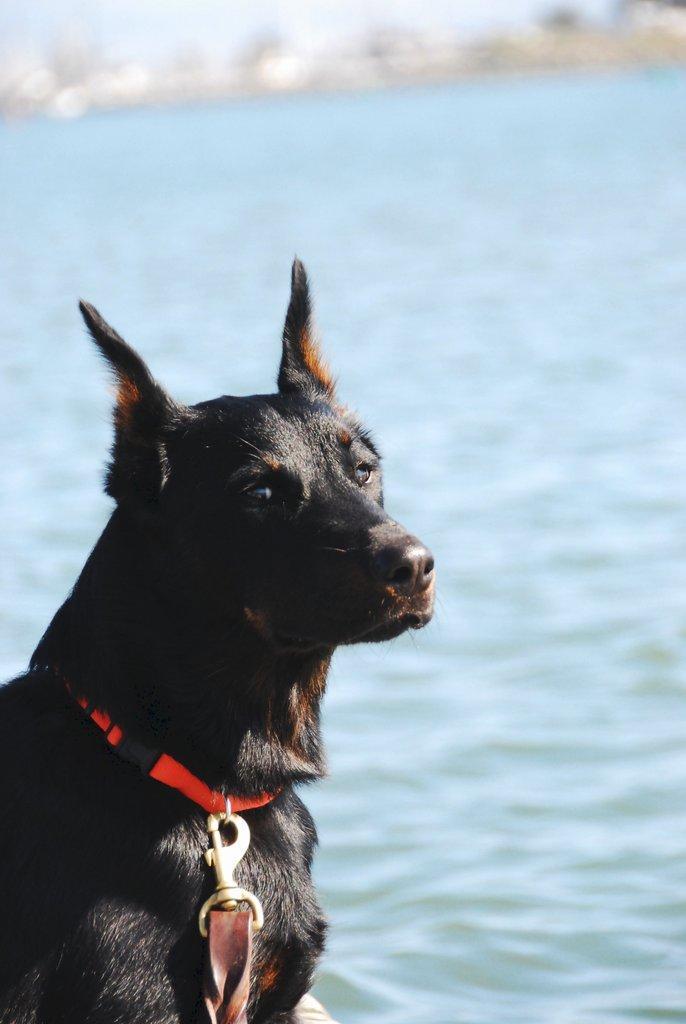Could you give a brief overview of what you see in this image? In this picture we can see a black color dog and a belt, in the background we can see water. 